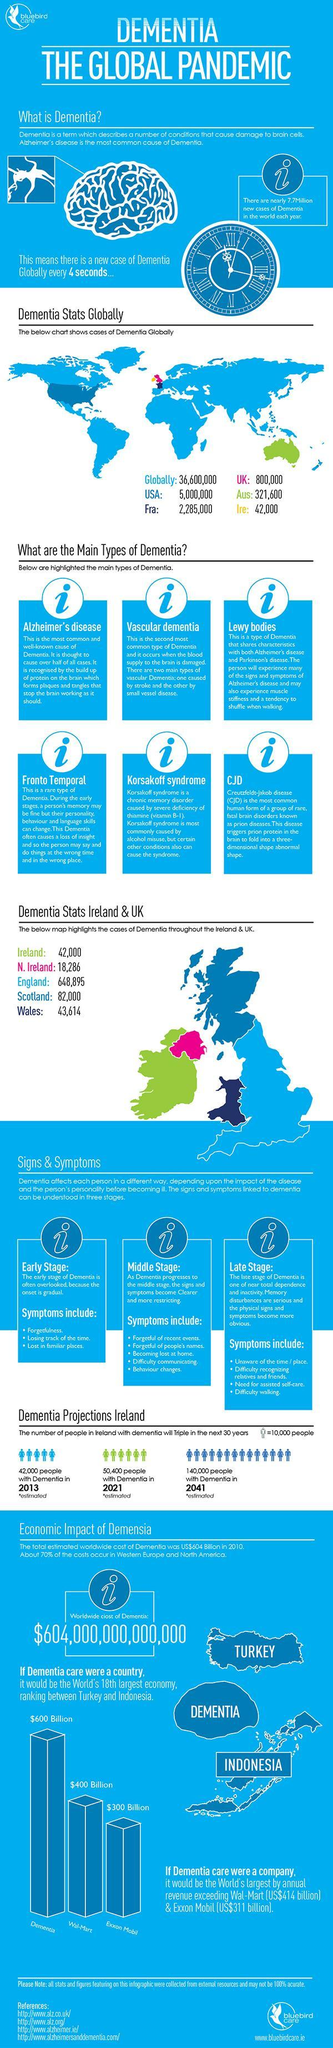Which country is represented by green colour in the world map?
Answer the question with a short phrase. AUS How many references are given? 4 Which place in Ireland and UK have the highest number of dementia cases? England By what number will people in Ireland with dementia increase from 2013 to 2041? 98,000 